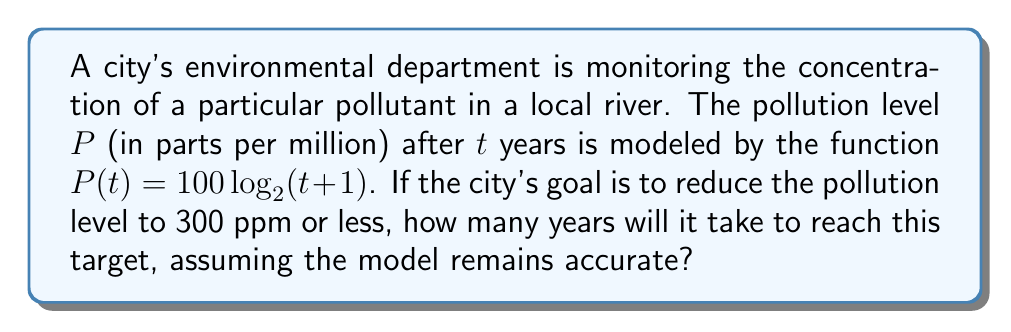Could you help me with this problem? To solve this problem, we need to use the given logarithmic function and solve for $t$ when $P(t) = 300$. Let's approach this step-by-step:

1) We start with the equation:
   $P(t) = 100 \log_2(t+1)$

2) We want to find $t$ when $P(t) = 300$, so we set up the equation:
   $300 = 100 \log_2(t+1)$

3) Divide both sides by 100:
   $3 = \log_2(t+1)$

4) To solve for $t$, we need to apply the inverse function of $\log_2$, which is $2^x$:
   $2^3 = t+1$

5) Simplify the left side:
   $8 = t+1$

6) Subtract 1 from both sides to isolate $t$:
   $7 = t$

Therefore, it will take 7 years for the pollution level to reduce to 300 ppm or less, according to this model.
Answer: 7 years 